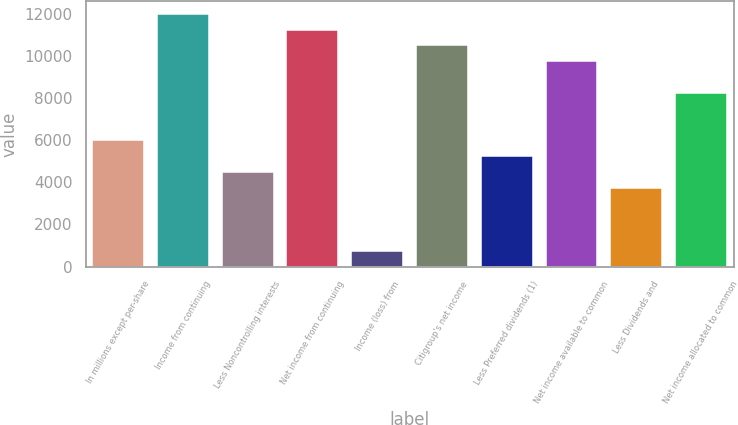Convert chart. <chart><loc_0><loc_0><loc_500><loc_500><bar_chart><fcel>In millions except per-share<fcel>Income from continuing<fcel>Less Noncontrolling interests<fcel>Net income from continuing<fcel>Income (loss) from<fcel>Citigroup's net income<fcel>Less Preferred dividends (1)<fcel>Net income available to common<fcel>Less Dividends and<fcel>Net income allocated to common<nl><fcel>6003.26<fcel>12006.2<fcel>4502.52<fcel>11255.9<fcel>750.67<fcel>10505.5<fcel>5252.89<fcel>9755.11<fcel>3752.15<fcel>8254.37<nl></chart> 